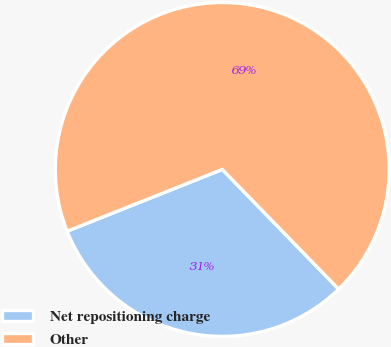Convert chart to OTSL. <chart><loc_0><loc_0><loc_500><loc_500><pie_chart><fcel>Net repositioning charge<fcel>Other<nl><fcel>31.25%<fcel>68.75%<nl></chart> 